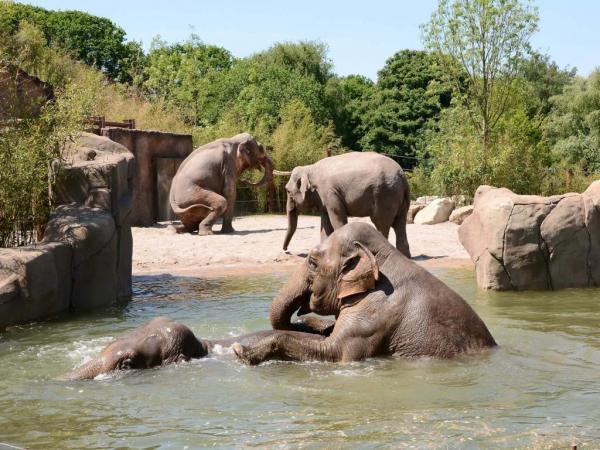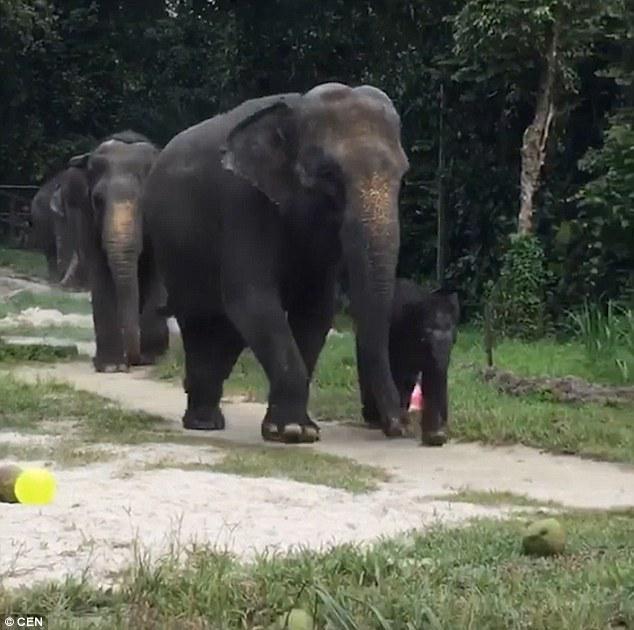The first image is the image on the left, the second image is the image on the right. Evaluate the accuracy of this statement regarding the images: "There are no baby elephants in the images.". Is it true? Answer yes or no. No. The first image is the image on the left, the second image is the image on the right. Analyze the images presented: Is the assertion "Each image contains multiple elephants, and the right image includes a baby elephant." valid? Answer yes or no. Yes. 